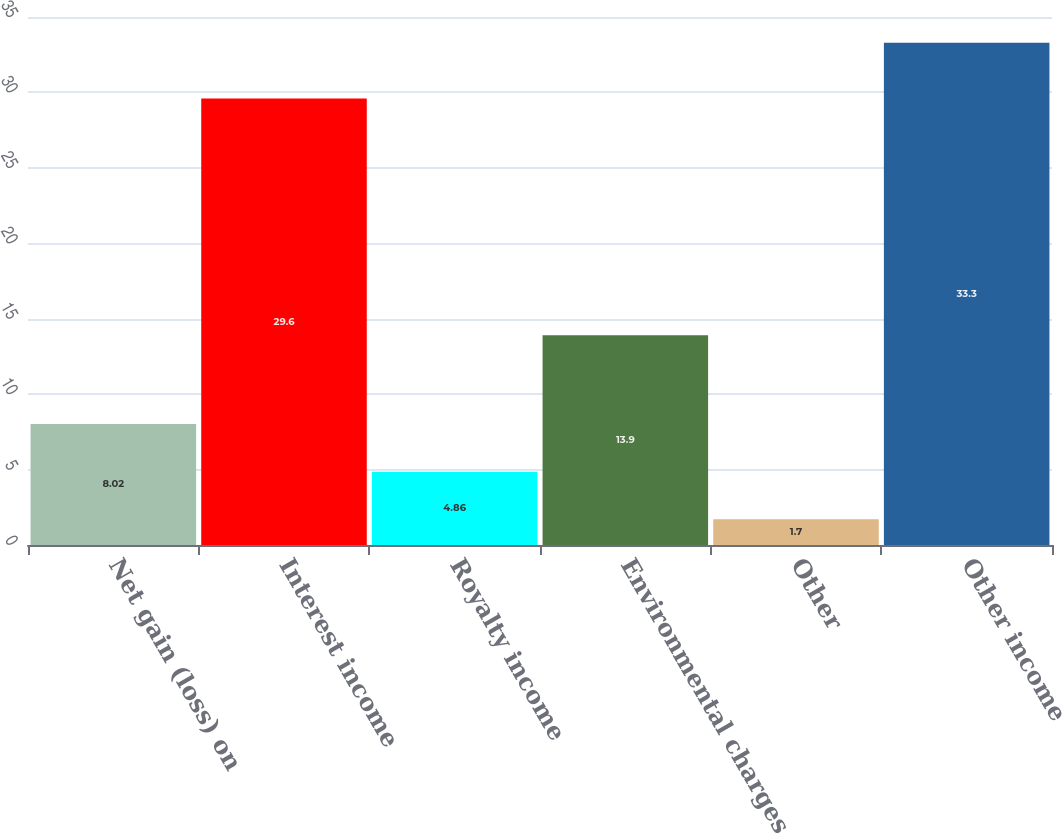Convert chart to OTSL. <chart><loc_0><loc_0><loc_500><loc_500><bar_chart><fcel>Net gain (loss) on<fcel>Interest income<fcel>Royalty income<fcel>Environmental charges<fcel>Other<fcel>Other income<nl><fcel>8.02<fcel>29.6<fcel>4.86<fcel>13.9<fcel>1.7<fcel>33.3<nl></chart> 